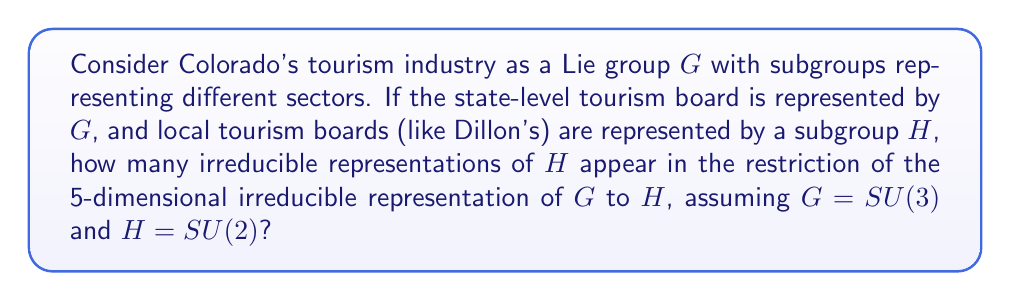What is the answer to this math problem? To solve this problem, we need to follow these steps:

1) First, we identify that $G = SU(3)$ and $H = SU(2)$. This represents the branching from state-level to local-level tourism boards.

2) We're dealing with a 5-dimensional irreducible representation of $SU(3)$. In the language of highest weights, this is the representation $(2,0)$.

3) The branching rule for $SU(3) \downarrow SU(2)$ is:

   $$(a,b) \rightarrow \bigoplus_{i=0}^a \bigoplus_{j=0}^b (a+b-i-2j)$$

4) For our case, $(2,0)$, we get:

   $$(2,0) \rightarrow \bigoplus_{i=0}^2 (2-i) = (2) \oplus (1) \oplus (0)$$

5) This means the 5-dimensional representation of $SU(3)$ branches into three irreducible representations of $SU(2)$:
   - $(2)$: 3-dimensional
   - $(1)$: 2-dimensional
   - $(0)$: 1-dimensional

6) Therefore, the number of irreducible representations of $H$ that appear in the restriction is 3.
Answer: 3 